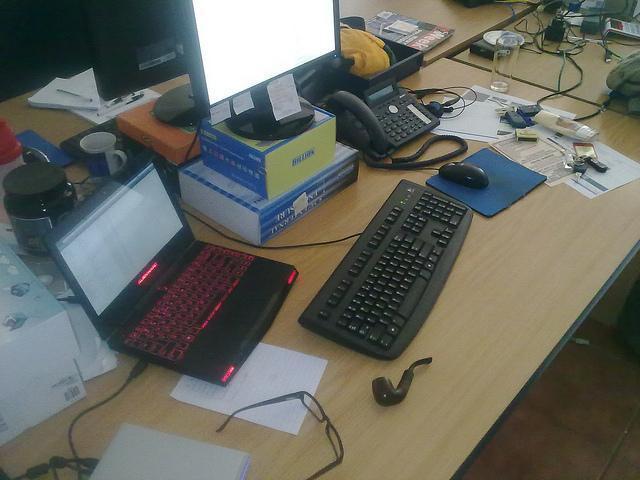What type of phone can this person use at the desk?
Answer the question by selecting the correct answer among the 4 following choices.
Options: Cellular, landline, payphone, rotary. Landline. 